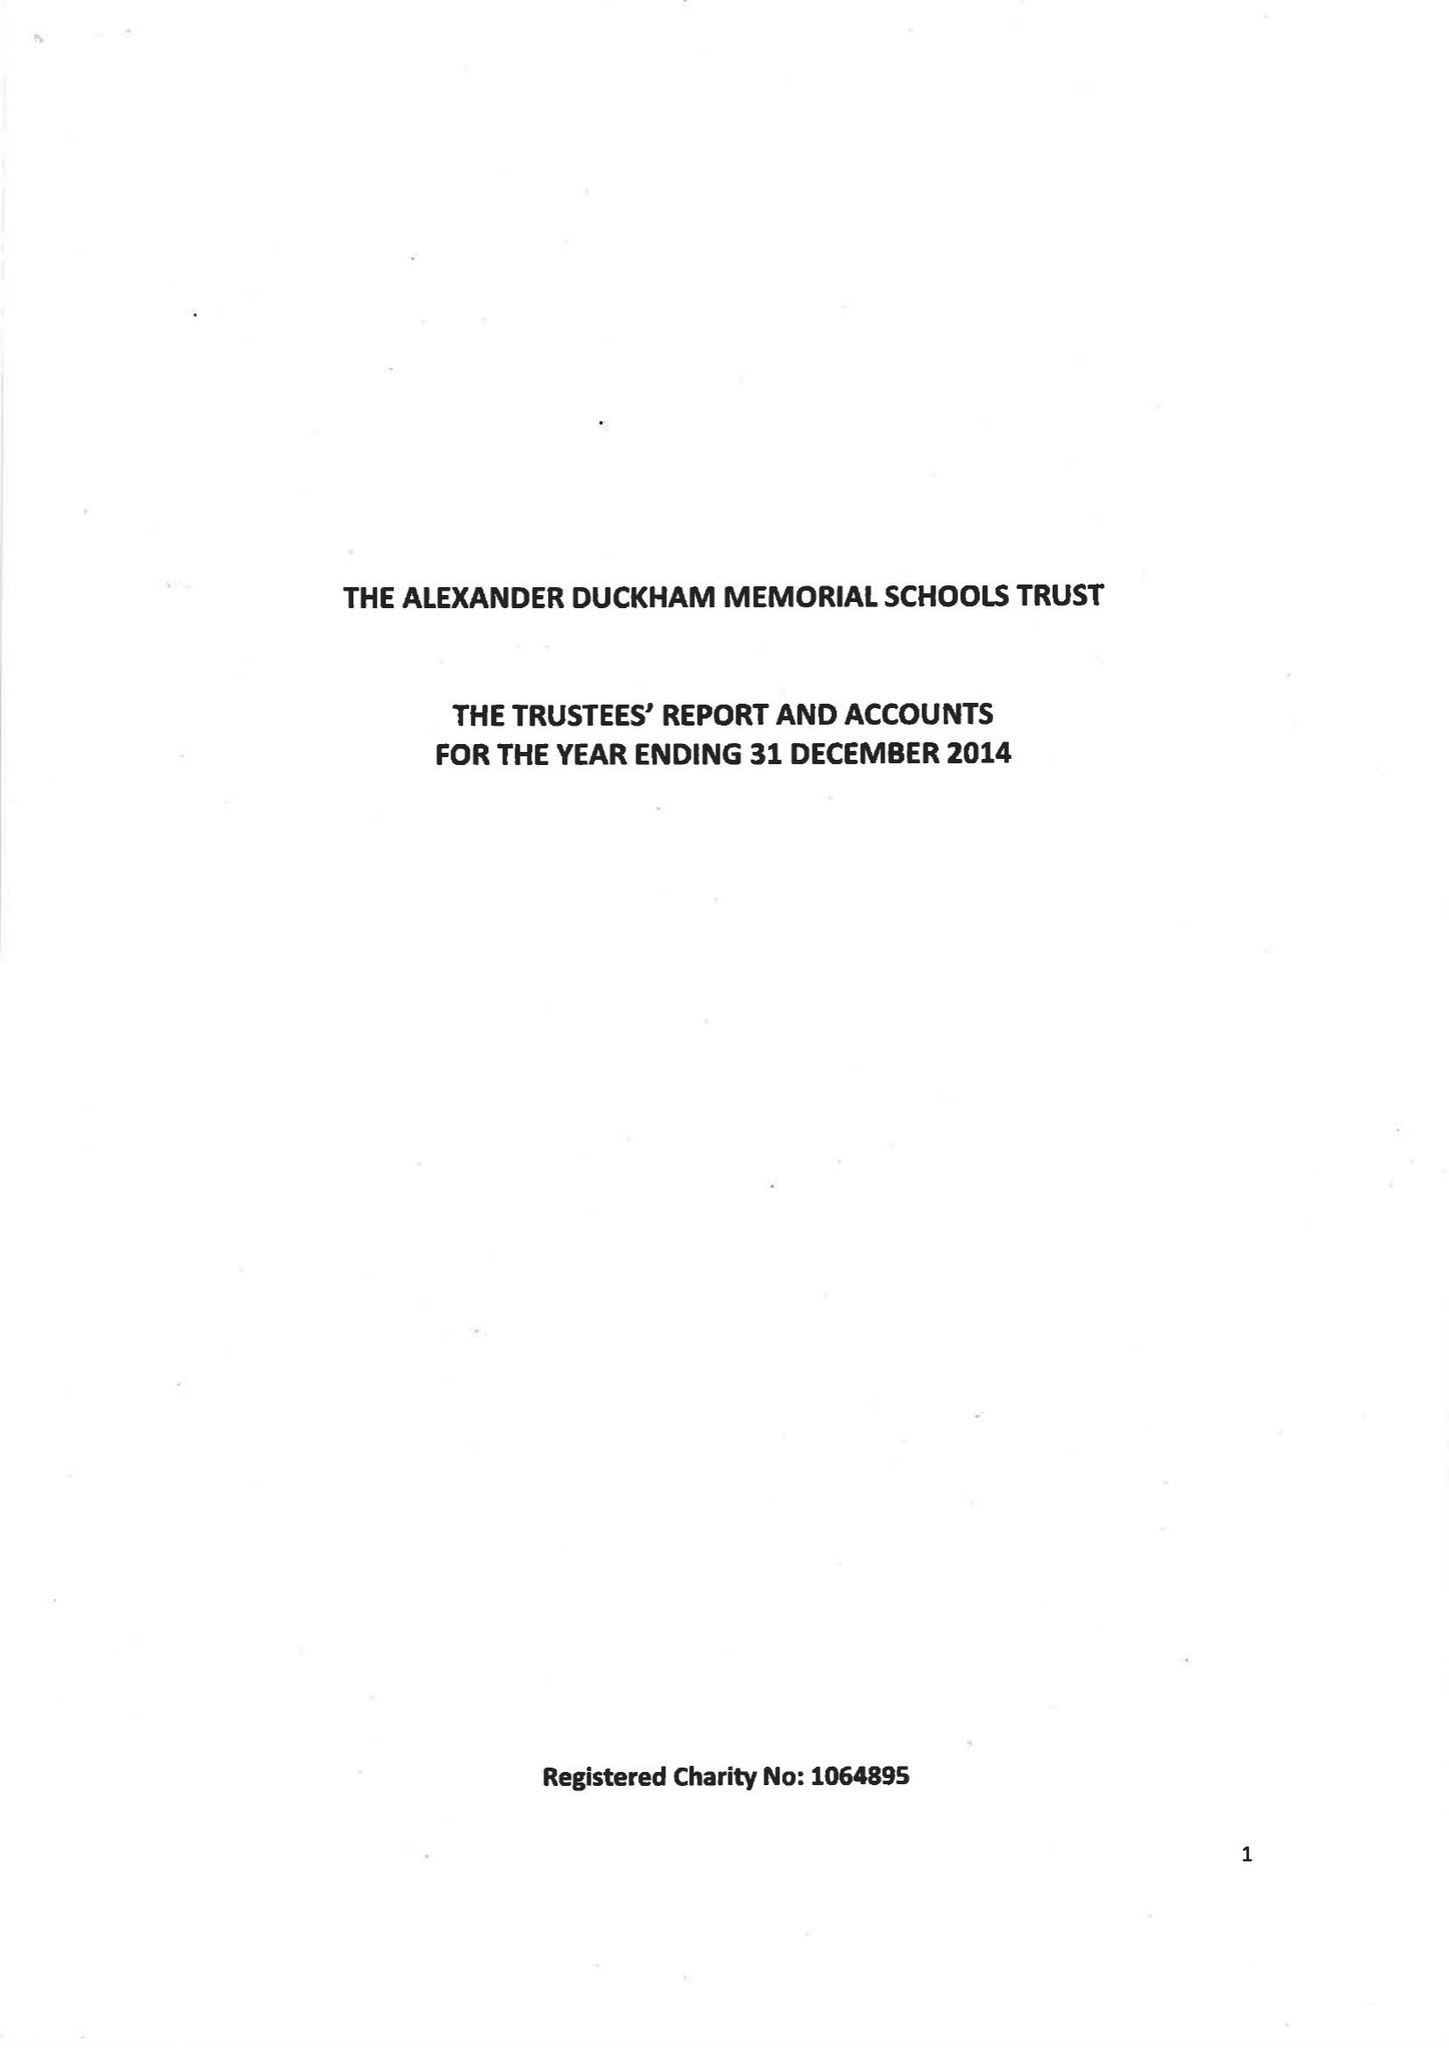What is the value for the address__post_town?
Answer the question using a single word or phrase. LONDON 